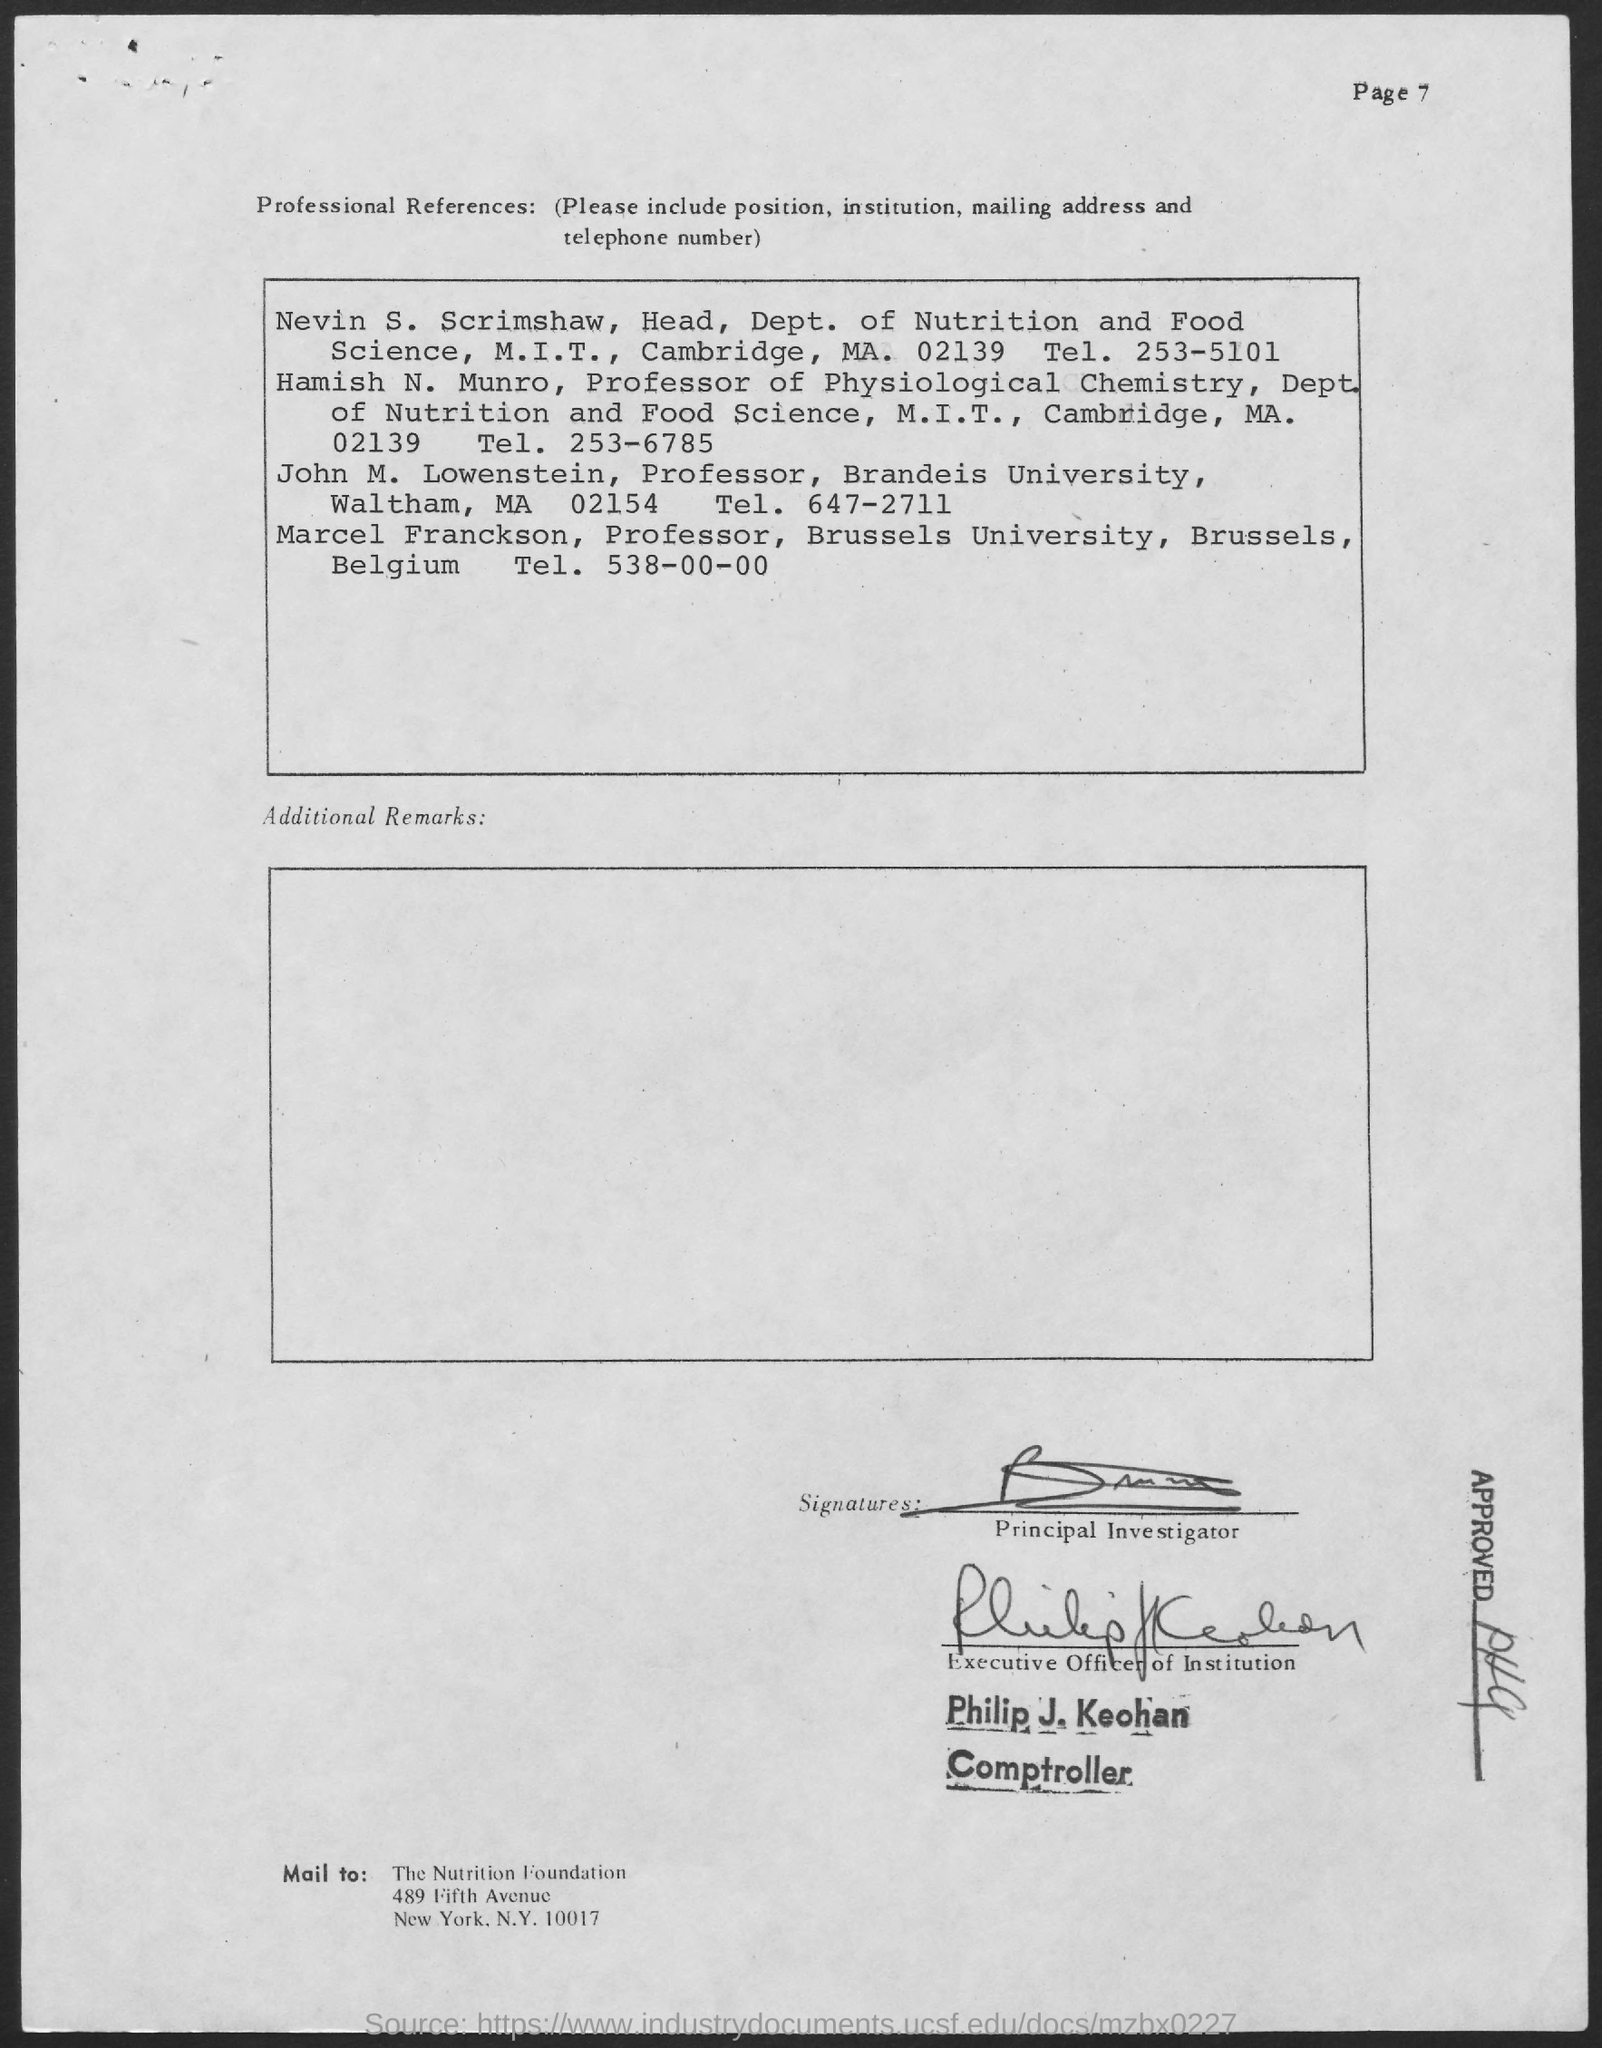Outline some significant characteristics in this image. The head of the Department of Nutrition and Food Science is Nevin S. Scrimshaw. John M. Lowenstein is the professor of Brandeis University. Marcel Franckson's telephone number is 538-00-00... Hamish N. Munro is a professor of physiological chemistry. Marcel Franckson is the professor at Brussels University. 